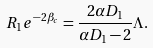<formula> <loc_0><loc_0><loc_500><loc_500>R _ { 1 } e ^ { - 2 \beta _ { c } } = \frac { 2 \alpha D _ { 1 } } { \alpha D _ { 1 } - 2 } \Lambda .</formula> 